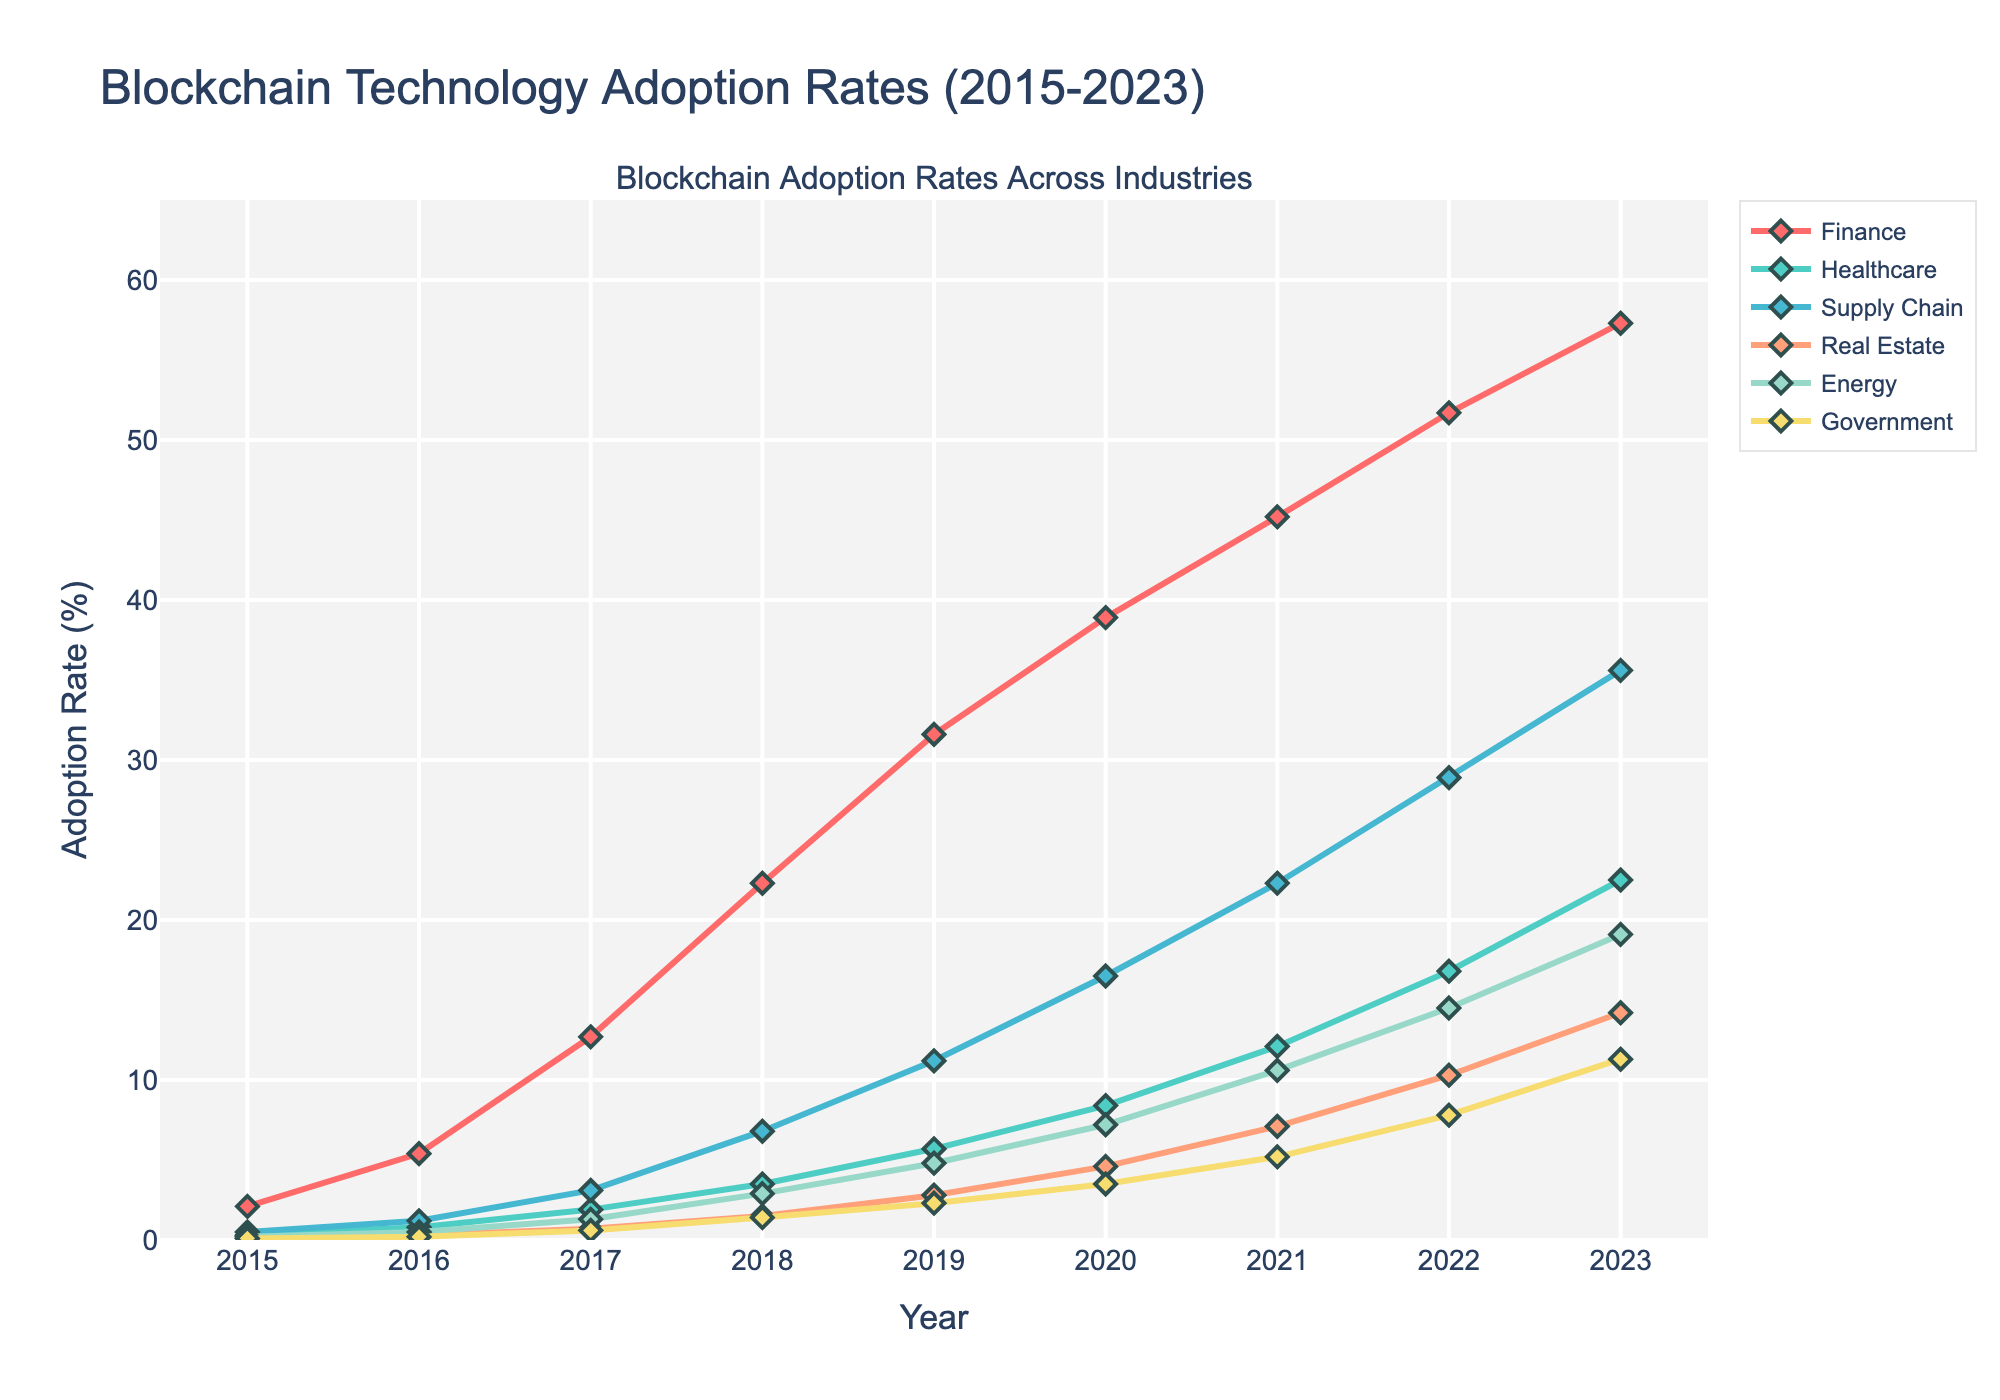6. What is the adoption rate increase for the Healthcare industry from 2015 to 2023? To calculate the adoption rate increase for the Healthcare industry from 2015 to 2023, you subtract the adoption rate in 2015 (0.3) from the adoption rate in 2023 (22.5). Hence, the increase is 22.5 - 0.3 = 22.2.
Answer: 22.2 Which industry had the highest adoption rate in 2020? Look at the adoption rates for all industries in 2020 and compare them. The Finance industry had the highest adoption rate in 2020 at 38.9%.
Answer: Finance By how much did the adoption rate of blockchain technology exceed the supply chain industry in 2023 compared to 2015? First, find the adoption rate for the Supply Chain industry for both 2015 and 2023: 0.5 and 35.6, respectively. The difference is 35.6 - 0.5 = 35.1.
Answer: 35.1 In which year did the Government industry see its first significant increase in adoption rate? Look at the year-over-year changes in adoption rates for the Government industry. The first significant increase is from 2017 to 2018, where it increased from 0.6 to 1.4.
Answer: 2018 What is the average adoption rate for the Real Estate industry over the provided years? Sum the adoption rates for the Real Estate industry (0.1 + 0.3 + 0.7 + 1.5 + 2.8 + 4.6 + 7.1 + 10.3 + 14.2) = 41.6%. The average is 41.6 / 9 = 4.62.
Answer: 4.62 Which industry had the lowest adoption rate in 2019? Compare the adoption rates for all industries in 2019. The Real Estate industry had the lowest adoption rate at 2.8%.
Answer: Real Estate How much did the adoption rate in the Energy industry increase between 2016 and 2018? Find the adoption rates for the Energy industry in 2016 (0.5) and in 2018 (2.9). The increase is 2.9 - 0.5 = 2.4.
Answer: 2.4 Compare the adoption rates of Finance and Supply Chain industries in 2022. Which is higher and by how much? The adoption rates for Finance and Supply Chain in 2022 are 51.7 and 28.9, respectively. The Finance industry's adoption rate is higher by 51.7 - 28.9 = 22.8.
Answer: Finance, by 22.8 What is the trend of adoption rates in the Government industry from 2015 to 2023? Observe the adoption rate curve for the Government industry from 2015 (0.1) to 2023 (11.3). The trend is an overall continuous increase over the years.
Answer: Continuous increase Which industry showed the second highest adoption rate in 2021, and what was the percentage? Look at the adoption rates in 2021; the second highest is Supply Chain with an adoption rate of 22.3%.
Answer: Supply Chain, 22.3 